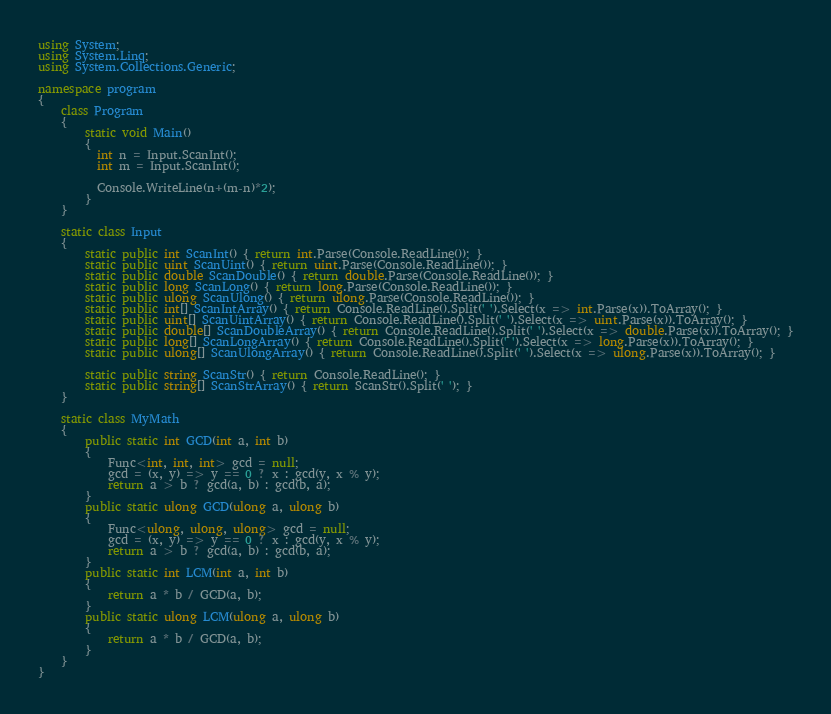Convert code to text. <code><loc_0><loc_0><loc_500><loc_500><_C#_>using System;
using System.Linq;
using System.Collections.Generic;

namespace program
{
    class Program
    {
        static void Main()
        {
          int n = Input.ScanInt();
          int m = Input.ScanInt();
          
          Console.WriteLine(n+(m-n)*2);
        }
    }

    static class Input
    {
        static public int ScanInt() { return int.Parse(Console.ReadLine()); }
        static public uint ScanUint() { return uint.Parse(Console.ReadLine()); }
        static public double ScanDouble() { return double.Parse(Console.ReadLine()); }
        static public long ScanLong() { return long.Parse(Console.ReadLine()); }
        static public ulong ScanUlong() { return ulong.Parse(Console.ReadLine()); }
        static public int[] ScanIntArray() { return Console.ReadLine().Split(' ').Select(x => int.Parse(x)).ToArray(); }
        static public uint[] ScanUintArray() { return Console.ReadLine().Split(' ').Select(x => uint.Parse(x)).ToArray(); }
        static public double[] ScanDoubleArray() { return Console.ReadLine().Split(' ').Select(x => double.Parse(x)).ToArray(); }
        static public long[] ScanLongArray() { return Console.ReadLine().Split(' ').Select(x => long.Parse(x)).ToArray(); }
        static public ulong[] ScanUlongArray() { return Console.ReadLine().Split(' ').Select(x => ulong.Parse(x)).ToArray(); }

        static public string ScanStr() { return Console.ReadLine(); }
        static public string[] ScanStrArray() { return ScanStr().Split(' '); }
    }

    static class MyMath
    {
        public static int GCD(int a, int b)
        {
            Func<int, int, int> gcd = null;
            gcd = (x, y) => y == 0 ? x : gcd(y, x % y);
            return a > b ? gcd(a, b) : gcd(b, a);
        }
        public static ulong GCD(ulong a, ulong b)
        {
            Func<ulong, ulong, ulong> gcd = null;
            gcd = (x, y) => y == 0 ? x : gcd(y, x % y);
            return a > b ? gcd(a, b) : gcd(b, a);
        }
        public static int LCM(int a, int b)
        {
            return a * b / GCD(a, b);
        }
        public static ulong LCM(ulong a, ulong b)
        {
            return a * b / GCD(a, b);
        }
    }
}
</code> 